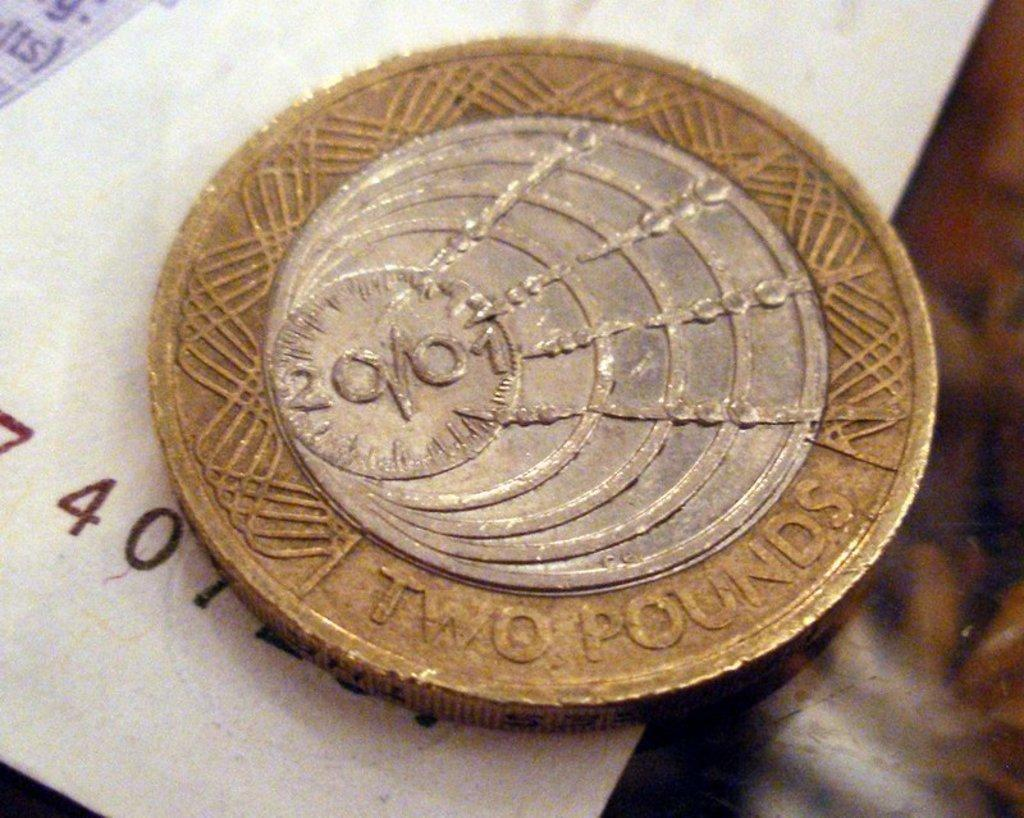<image>
Offer a succinct explanation of the picture presented. A round gold coin with a silver circle in the middle that is two pounds laying on a white piece of paper. 